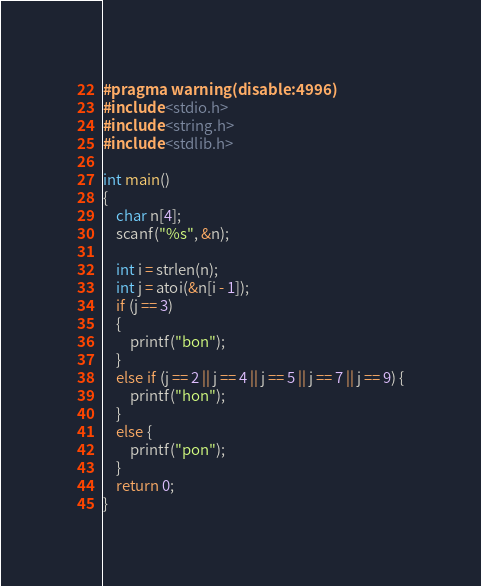Convert code to text. <code><loc_0><loc_0><loc_500><loc_500><_C_>#pragma warning(disable:4996)
#include <stdio.h>
#include <string.h>
#include <stdlib.h>

int main()
{
	char n[4];
	scanf("%s", &n);

	int i = strlen(n);
	int j = atoi(&n[i - 1]);
	if (j == 3) 
	{
		printf("bon");
	}
	else if (j == 2 || j == 4 || j == 5 || j == 7 || j == 9) {
		printf("hon");
	}
	else {
		printf("pon");
	}
	return 0;
}</code> 